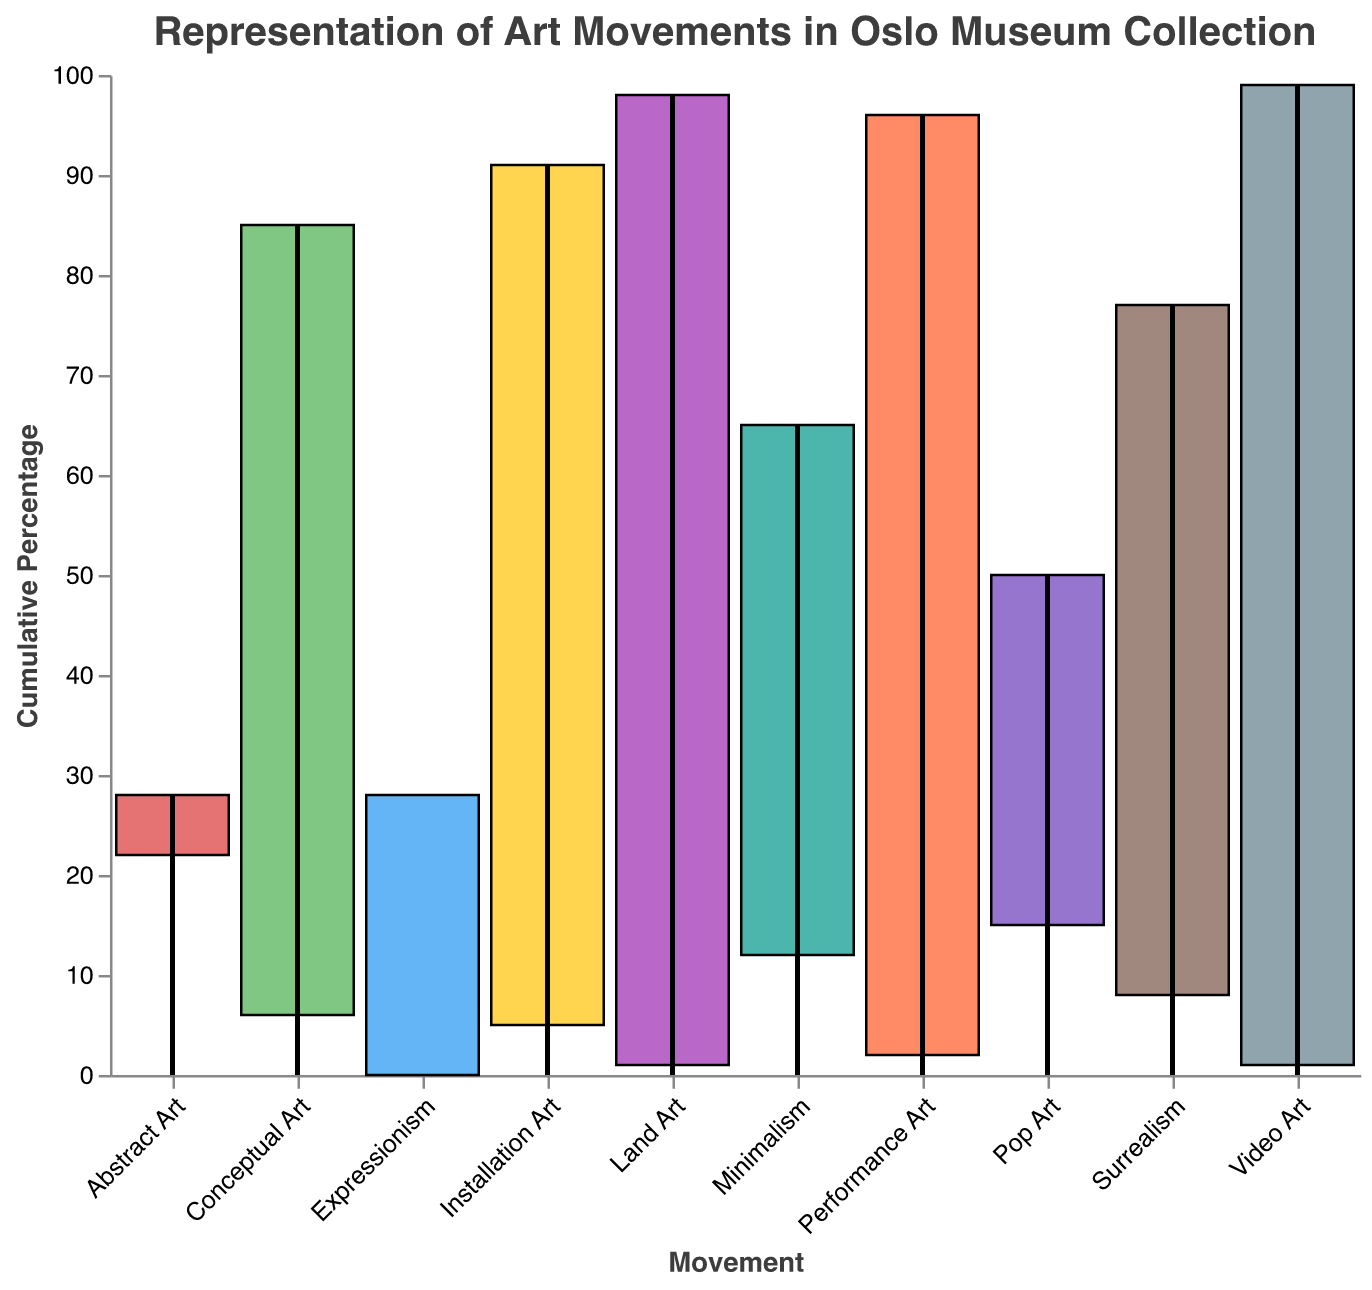What is the title of the chart? The title of the chart is displayed at the top and reads "Representation of Art Movements in Oslo Museum Collection".
Answer: Representation of Art Movements in Oslo Museum Collection Which art movement has the highest representation in the museum's collection? Looking at the Waterfall Chart, the art movement with the highest percentage is the first bar which represents "Expressionism" at 28%.
Answer: Expressionism What percentage of the museum's collection is composed of Abstract Art and Pop Art? Add the percentages of Abstract Art (22%) and Pop Art (15%), which are given directly in the chart. The total is 22% + 15% = 37%.
Answer: 37% How many art movements are included in this chart? Count the number of distinct bars in the Waterfall Chart, each representing a different art movement. There are 10 bars.
Answer: 10 Which two art movements combined comprise exactly 2% of the collection? The chart shows that "Performance Art" and "Land Art" each have a percentage of 2% and 1%, respectively, combining for 2%.
Answer: Performance Art and Land Art What is the cumulative percentage before adding Minimalism? The cumulative percentage before Minimalism is the cumulative percentage of the previous movement, which is Pop Art. The chart shows this is 65%.
Answer: 65% Which is more represented in the collection: Surrealism or Conceptual Art? The chart shows Surrealism at 8% and Conceptual Art at 6%. Comparing these, Surrealism has a higher percentage than Conceptual Art.
Answer: Surrealism What is the total percentage represented by the first three art movements? The percentages of the first three art movements are Expressionism (28%), Abstract Art (22%), and Pop Art (15%). Adding these: 28% + 22% + 15% = 65%.
Answer: 65% Which two consecutive art movements have the smallest combined percentage? Observing the chart, "Land Art" and "Video Art" each have 1%, making their combined representation 1% + 1% = 2%, the smallest among consecutive pairs.
Answer: Land Art and Video Art 